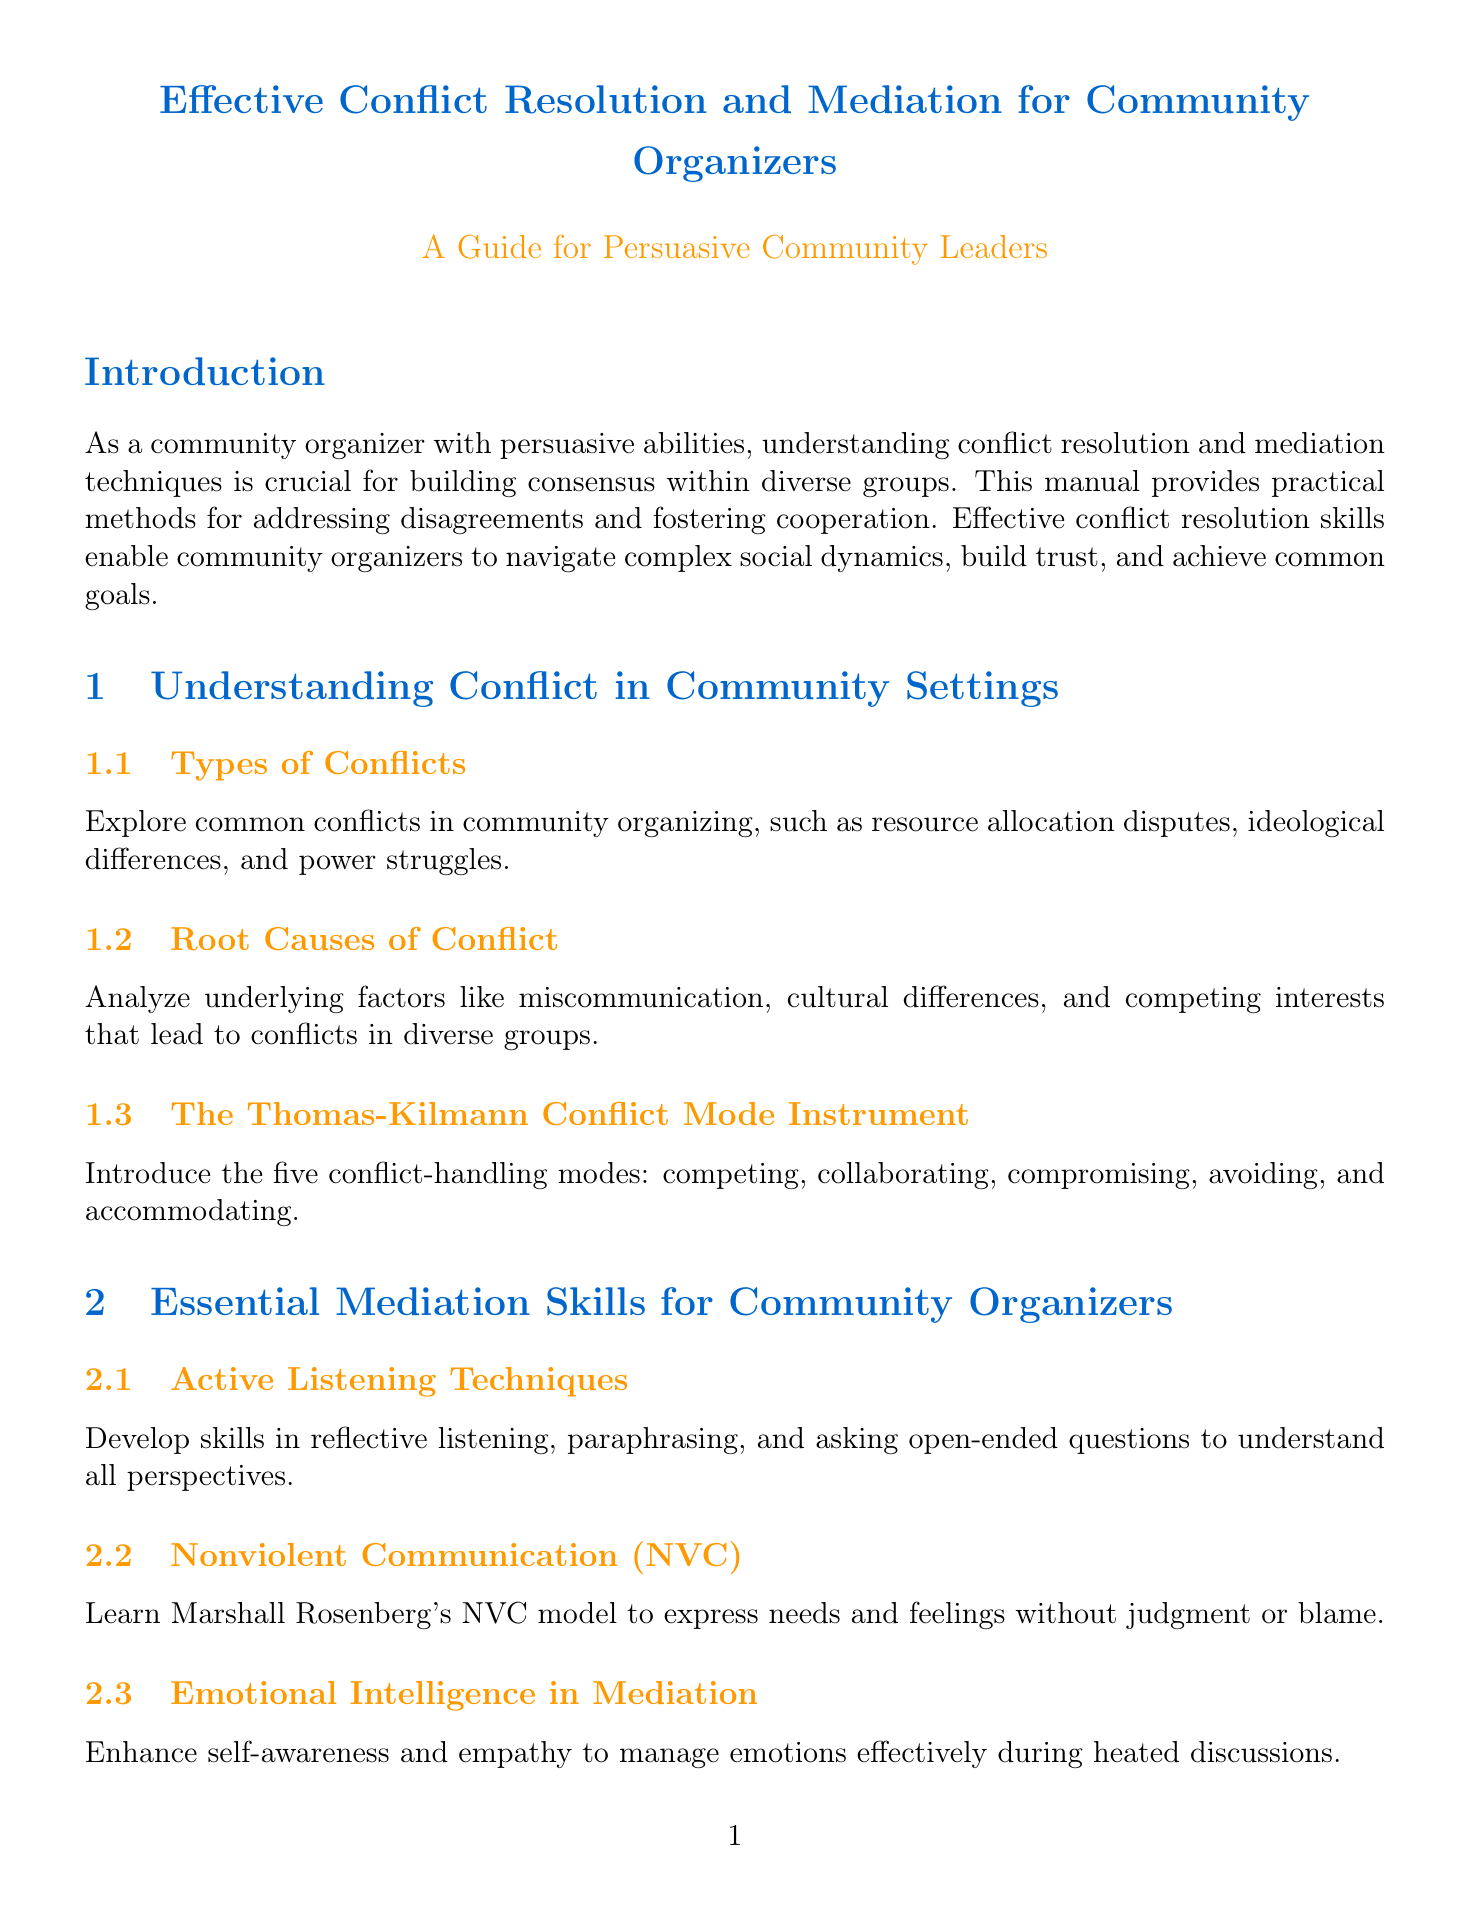What is the title of the manual? The title of the manual is explicitly stated at the beginning of the document.
Answer: Effective Conflict Resolution and Mediation for Community Organizers What are the three types of conflicts listed? The types of conflicts can be found in the respective section, outlining various common conflicts in community organizing.
Answer: Resource allocation disputes, ideological differences, power struggles Who developed the Nonviolent Communication model? The document specifies the creator of the Nonviolent Communication model in a section focused on essential mediation skills.
Answer: Marshall Rosenberg What is the first exercise listed in the document? The exercises section outlines various practices for community organizers to enhance their conflict resolution skills.
Answer: Role-Playing Difficult Conversations Which case study examines the Black Lives Matter movement? The case studies section includes various examples of conflict resolution within notable movements.
Answer: Resolving Tensions in the Black Lives Matter Movement What online platform is suggested for remote mediation sessions? The manual suggests specific tools for online dispute resolution in a particular section dedicated to leveraging technology.
Answer: Modria How many conflict-handling modes are introduced in the Thomas-Kilmann Conflict Mode Instrument? The number of modes is specified in the section related to understanding conflict handling.
Answer: Five What is the purpose of the Gradients of Agreement Scale? The document describes the tool's specific application in measuring consensus within groups.
Answer: Measure levels of consensus What is the focus of Appreciative Inquiry in the document? The section on building consensus highlights the approach's aim regarding community building.
Answer: Focus on strengths and shared visions 